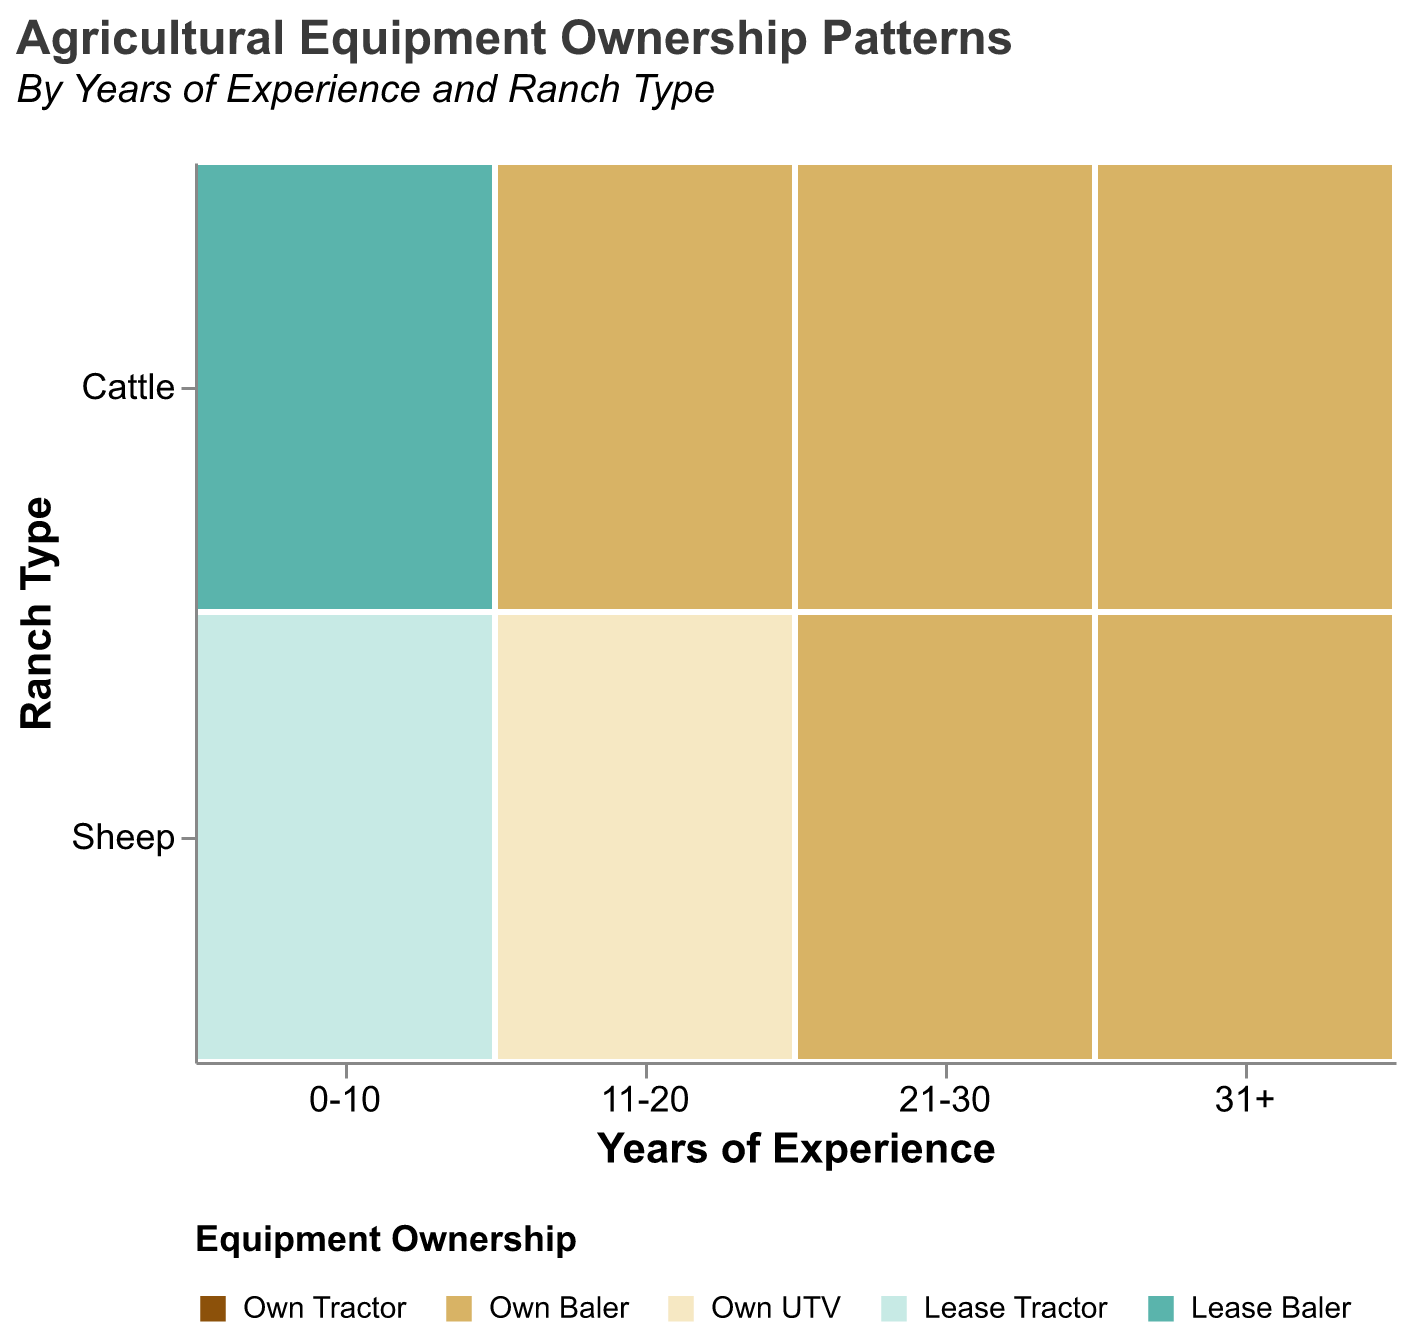What is the title of the figure? The title of a figure is typically placed at the top for easy identification. In this case, it is clearly mentioned in the code snippet provided.
Answer: Agricultural Equipment Ownership Patterns How many distinct equipment ownership types are displayed in the legend? The legend shows the different types of equipment ownership and their associated colors. Count each unique label in the legend.
Answer: 5 What ranch type is associated with "Own UTV"? Look at the different ranch types and equipment ownership combinations. Check which ranch type is associated with the "Own UTV" label.
Answer: Sheep Which years of experience category has both “Own Baler” and “Lease Baler” for Cattle ranchers? Examine the "Years of Experience" categories for Cattle ranchers and identify the one that includes both “Own Baler” and “Lease Baler” in equipment ownership.
Answer: 0-10 How does equipment ownership for "Own Tractor" vary between Sheep ranchers with 0-10 years of experience and those with 31+ years? Compare the presence of "Own Tractor" ownership for Sheep ranchers in the two specified experience ranges. Note if there's a difference in occurrence.
Answer: Both own tractors In the 21-30 years of experience category, which ranch type owns more types of equipment? Compare the equipment owned by each ranch type within the 21-30 years of experience category. Count the types of equipment for each to determine which owns more.
Answer: Both own the same number of equipment types Compare the equipment ownership patterns between Cattle and Sheep ranchers in the 11-20 years of experience category. For the 11-20 years of experience category, compare the types of equipment owned by both Cattle and Sheep ranchers. Identify any differences or similarities.
Answer: Both own tractors, Cattle also own balers, Sheep own UTVs Which equipment ownership type is the most consistent across all years of experience for Cattle ranchers? For each years of experience category for Cattle ranchers, identify the equipment ownership types and see which one appears consistently in all categories.
Answer: Own Tractor What is unique about equipment ownership for Sheep ranchers in the 0-10 years of experience category? Focus on the 0-10 years of experience category for Sheep ranchers and identify any unique or distinct equipment ownership patterns compared to other categories.
Answer: Own UTV, Lease Tractor 